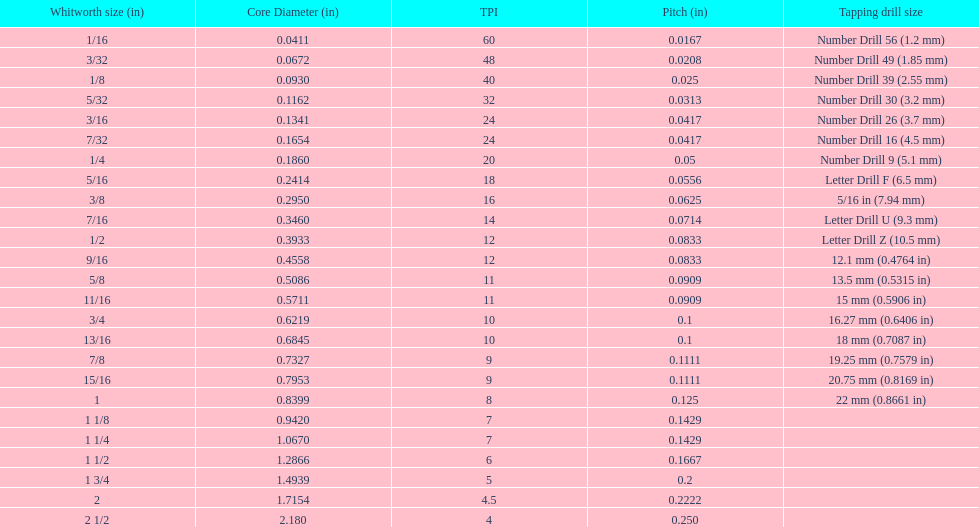What is the least core diameter (in)? 0.0411. 